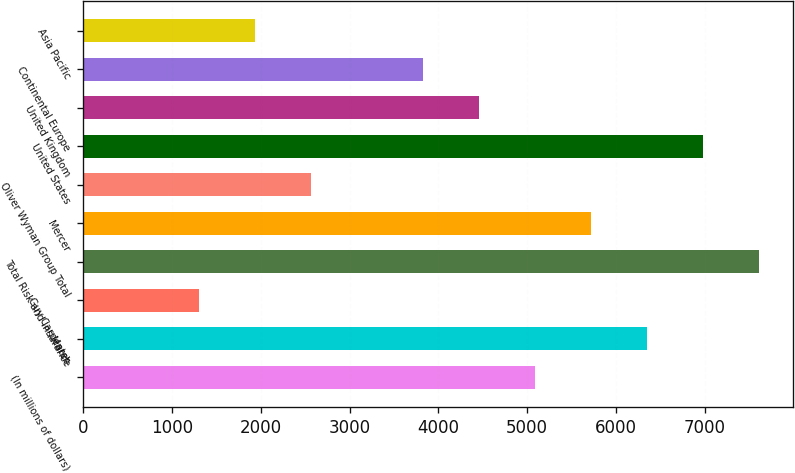Convert chart. <chart><loc_0><loc_0><loc_500><loc_500><bar_chart><fcel>(In millions of dollars)<fcel>Marsh<fcel>Guy Carpenter<fcel>Total Risk and Insurance<fcel>Mercer<fcel>Oliver Wyman Group Total<fcel>United States<fcel>United Kingdom<fcel>Continental Europe<fcel>Asia Pacific<nl><fcel>5087.8<fcel>6350<fcel>1301.2<fcel>7612.2<fcel>5718.9<fcel>2563.4<fcel>6981.1<fcel>4456.7<fcel>3825.6<fcel>1932.3<nl></chart> 